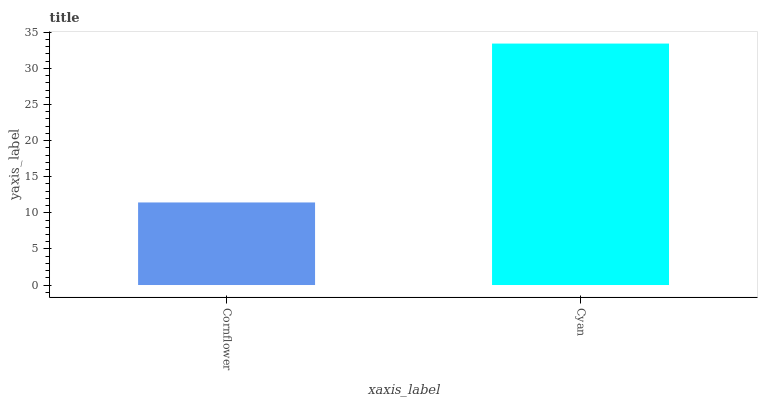Is Cornflower the minimum?
Answer yes or no. Yes. Is Cyan the maximum?
Answer yes or no. Yes. Is Cyan the minimum?
Answer yes or no. No. Is Cyan greater than Cornflower?
Answer yes or no. Yes. Is Cornflower less than Cyan?
Answer yes or no. Yes. Is Cornflower greater than Cyan?
Answer yes or no. No. Is Cyan less than Cornflower?
Answer yes or no. No. Is Cyan the high median?
Answer yes or no. Yes. Is Cornflower the low median?
Answer yes or no. Yes. Is Cornflower the high median?
Answer yes or no. No. Is Cyan the low median?
Answer yes or no. No. 